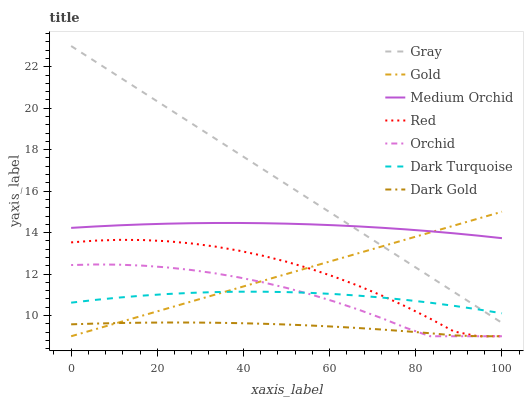Does Gold have the minimum area under the curve?
Answer yes or no. No. Does Gold have the maximum area under the curve?
Answer yes or no. No. Is Dark Gold the smoothest?
Answer yes or no. No. Is Dark Gold the roughest?
Answer yes or no. No. Does Dark Turquoise have the lowest value?
Answer yes or no. No. Does Gold have the highest value?
Answer yes or no. No. Is Dark Turquoise less than Medium Orchid?
Answer yes or no. Yes. Is Dark Turquoise greater than Dark Gold?
Answer yes or no. Yes. Does Dark Turquoise intersect Medium Orchid?
Answer yes or no. No. 